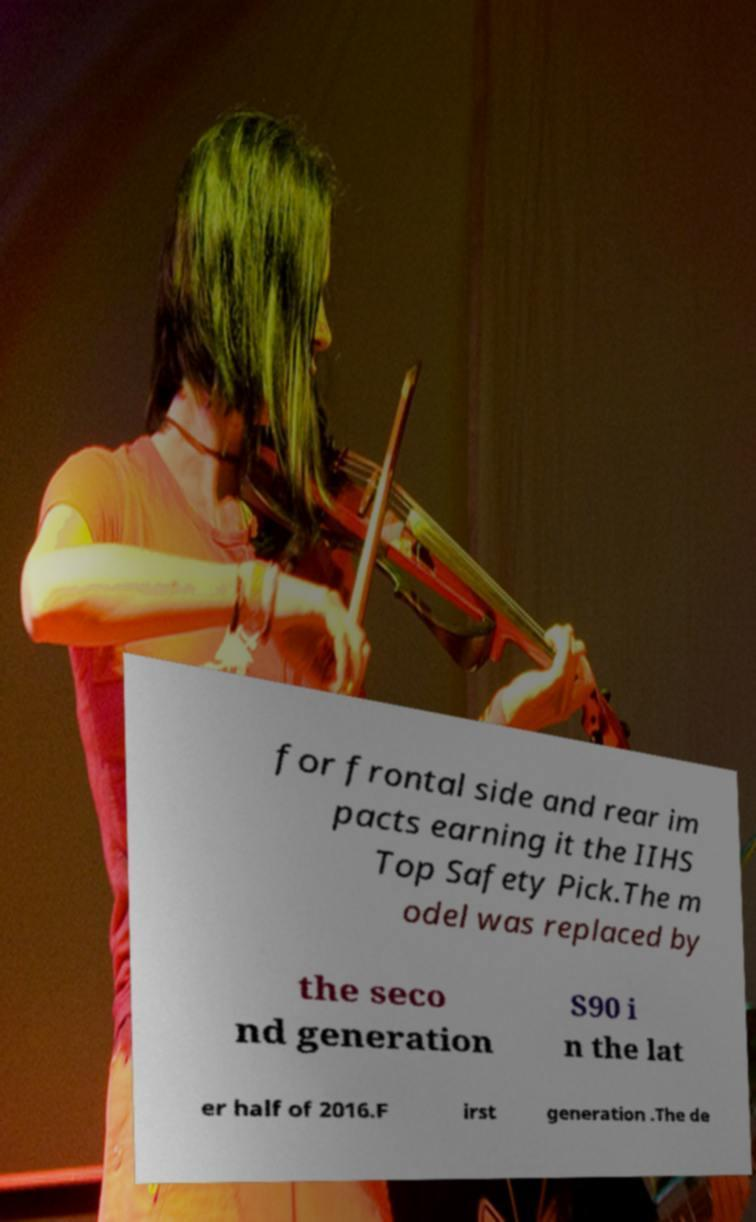There's text embedded in this image that I need extracted. Can you transcribe it verbatim? for frontal side and rear im pacts earning it the IIHS Top Safety Pick.The m odel was replaced by the seco nd generation S90 i n the lat er half of 2016.F irst generation .The de 